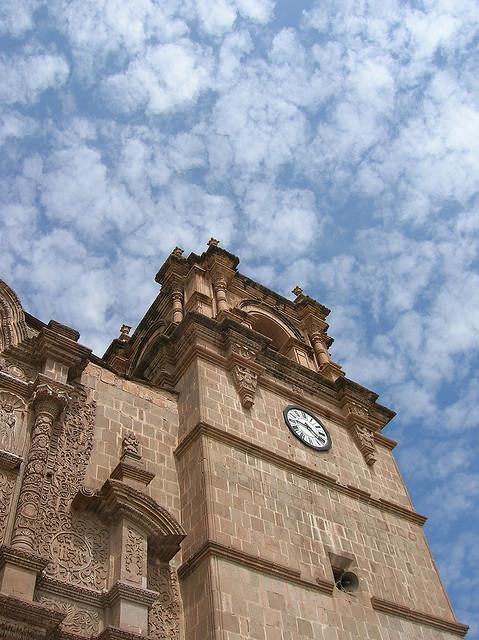Is it sunny?
Concise answer only. Yes. Does the clock work?
Short answer required. Yes. How many bricks make up the section of building visible in the picture?
Keep it brief. No idea. 